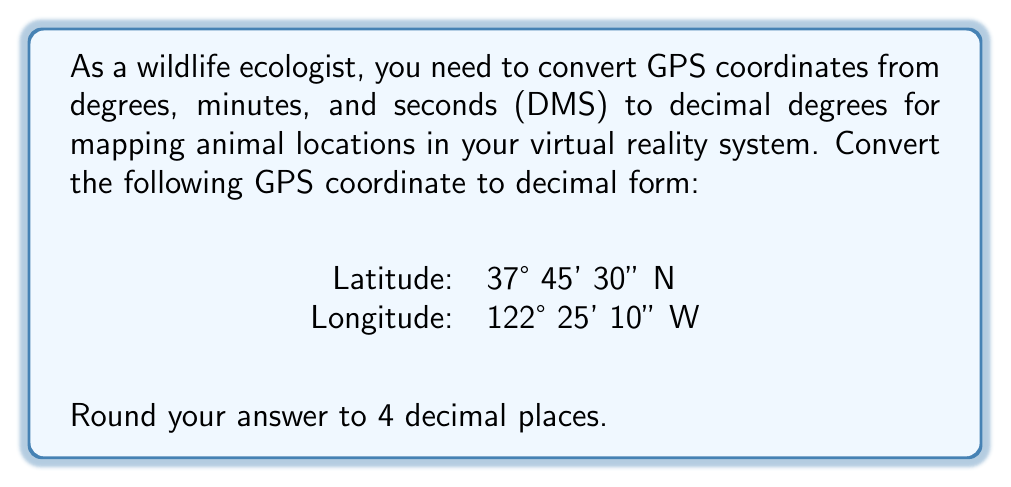Give your solution to this math problem. To convert GPS coordinates from DMS (degrees, minutes, seconds) to decimal degrees, we follow these steps:

1. For latitude:
   a. Start with the degrees: 37°
   b. Add the minutes divided by 60: 45' ÷ 60 = 0.75°
   c. Add the seconds divided by 3600: 30" ÷ 3600 = 0.0083333°
   d. Sum these values: 37 + 0.75 + 0.0083333 = 37.7583333°
   e. Keep the positive sign for N (negative for S)

2. For longitude:
   a. Start with the degrees: 122°
   b. Add the minutes divided by 60: 25' ÷ 60 = 0.4166667°
   c. Add the seconds divided by 3600: 10" ÷ 3600 = 0.0027778°
   d. Sum these values: 122 + 0.4166667 + 0.0027778 = 122.4194445°
   e. Use a negative sign for W (positive for E)

3. Round both results to 4 decimal places.

Mathematically, we can express this as:

For latitude:
$$ 37 + \frac{45}{60} + \frac{30}{3600} = 37.7583333° $$

For longitude:
$$ -(122 + \frac{25}{60} + \frac{10}{3600}) = -122.4194445° $$

Rounding to 4 decimal places:
Latitude: 37.7583° N
Longitude: 122.4194° W
Answer: 37.7583° N, 122.4194° W 